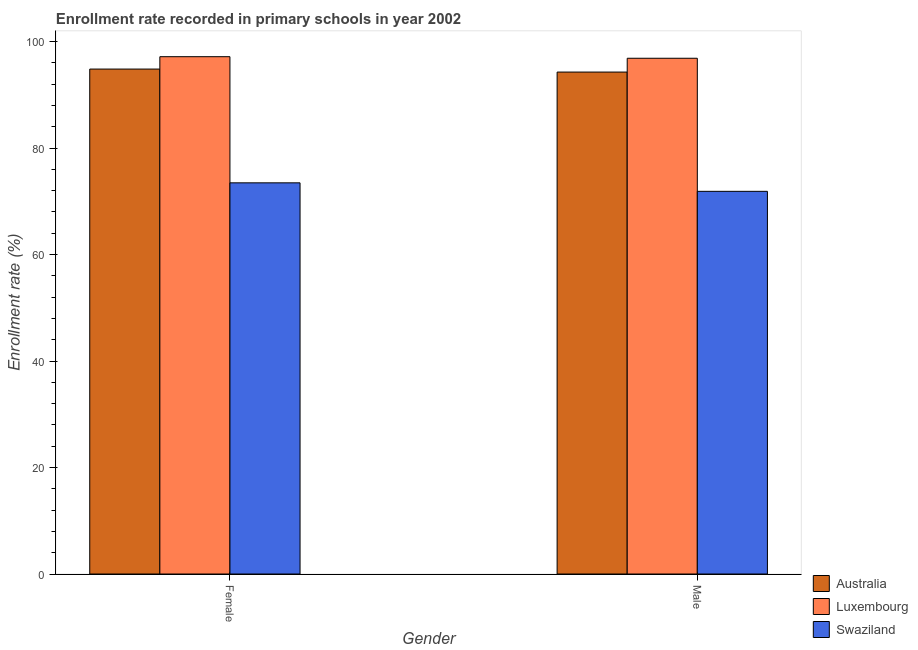Are the number of bars per tick equal to the number of legend labels?
Your answer should be compact. Yes. How many bars are there on the 2nd tick from the right?
Ensure brevity in your answer.  3. What is the label of the 2nd group of bars from the left?
Give a very brief answer. Male. What is the enrollment rate of female students in Australia?
Offer a terse response. 94.83. Across all countries, what is the maximum enrollment rate of female students?
Provide a short and direct response. 97.16. Across all countries, what is the minimum enrollment rate of male students?
Your response must be concise. 71.87. In which country was the enrollment rate of male students maximum?
Your response must be concise. Luxembourg. In which country was the enrollment rate of male students minimum?
Make the answer very short. Swaziland. What is the total enrollment rate of male students in the graph?
Make the answer very short. 263.01. What is the difference between the enrollment rate of male students in Luxembourg and that in Australia?
Make the answer very short. 2.59. What is the difference between the enrollment rate of female students in Luxembourg and the enrollment rate of male students in Swaziland?
Your response must be concise. 25.29. What is the average enrollment rate of male students per country?
Provide a short and direct response. 87.67. What is the difference between the enrollment rate of female students and enrollment rate of male students in Australia?
Provide a succinct answer. 0.56. In how many countries, is the enrollment rate of female students greater than 32 %?
Ensure brevity in your answer.  3. What is the ratio of the enrollment rate of male students in Australia to that in Swaziland?
Provide a succinct answer. 1.31. In how many countries, is the enrollment rate of female students greater than the average enrollment rate of female students taken over all countries?
Offer a very short reply. 2. What does the 3rd bar from the left in Female represents?
Your answer should be compact. Swaziland. What does the 3rd bar from the right in Female represents?
Offer a terse response. Australia. How many bars are there?
Offer a terse response. 6. How many countries are there in the graph?
Make the answer very short. 3. What is the difference between two consecutive major ticks on the Y-axis?
Ensure brevity in your answer.  20. Does the graph contain any zero values?
Your answer should be very brief. No. How many legend labels are there?
Make the answer very short. 3. What is the title of the graph?
Make the answer very short. Enrollment rate recorded in primary schools in year 2002. What is the label or title of the X-axis?
Your response must be concise. Gender. What is the label or title of the Y-axis?
Offer a terse response. Enrollment rate (%). What is the Enrollment rate (%) of Australia in Female?
Your answer should be very brief. 94.83. What is the Enrollment rate (%) in Luxembourg in Female?
Your response must be concise. 97.16. What is the Enrollment rate (%) in Swaziland in Female?
Keep it short and to the point. 73.47. What is the Enrollment rate (%) in Australia in Male?
Give a very brief answer. 94.27. What is the Enrollment rate (%) in Luxembourg in Male?
Make the answer very short. 96.87. What is the Enrollment rate (%) of Swaziland in Male?
Provide a succinct answer. 71.87. Across all Gender, what is the maximum Enrollment rate (%) in Australia?
Your answer should be compact. 94.83. Across all Gender, what is the maximum Enrollment rate (%) of Luxembourg?
Offer a terse response. 97.16. Across all Gender, what is the maximum Enrollment rate (%) in Swaziland?
Make the answer very short. 73.47. Across all Gender, what is the minimum Enrollment rate (%) in Australia?
Make the answer very short. 94.27. Across all Gender, what is the minimum Enrollment rate (%) of Luxembourg?
Ensure brevity in your answer.  96.87. Across all Gender, what is the minimum Enrollment rate (%) of Swaziland?
Give a very brief answer. 71.87. What is the total Enrollment rate (%) of Australia in the graph?
Your response must be concise. 189.11. What is the total Enrollment rate (%) in Luxembourg in the graph?
Your response must be concise. 194.03. What is the total Enrollment rate (%) of Swaziland in the graph?
Keep it short and to the point. 145.34. What is the difference between the Enrollment rate (%) of Australia in Female and that in Male?
Provide a short and direct response. 0.56. What is the difference between the Enrollment rate (%) in Luxembourg in Female and that in Male?
Offer a terse response. 0.29. What is the difference between the Enrollment rate (%) of Swaziland in Female and that in Male?
Your answer should be compact. 1.6. What is the difference between the Enrollment rate (%) in Australia in Female and the Enrollment rate (%) in Luxembourg in Male?
Provide a short and direct response. -2.03. What is the difference between the Enrollment rate (%) of Australia in Female and the Enrollment rate (%) of Swaziland in Male?
Provide a short and direct response. 22.96. What is the difference between the Enrollment rate (%) in Luxembourg in Female and the Enrollment rate (%) in Swaziland in Male?
Provide a short and direct response. 25.29. What is the average Enrollment rate (%) in Australia per Gender?
Your response must be concise. 94.55. What is the average Enrollment rate (%) of Luxembourg per Gender?
Your answer should be very brief. 97.01. What is the average Enrollment rate (%) of Swaziland per Gender?
Your answer should be very brief. 72.67. What is the difference between the Enrollment rate (%) in Australia and Enrollment rate (%) in Luxembourg in Female?
Provide a short and direct response. -2.33. What is the difference between the Enrollment rate (%) in Australia and Enrollment rate (%) in Swaziland in Female?
Your answer should be very brief. 21.37. What is the difference between the Enrollment rate (%) in Luxembourg and Enrollment rate (%) in Swaziland in Female?
Provide a succinct answer. 23.69. What is the difference between the Enrollment rate (%) of Australia and Enrollment rate (%) of Luxembourg in Male?
Your answer should be very brief. -2.59. What is the difference between the Enrollment rate (%) of Australia and Enrollment rate (%) of Swaziland in Male?
Provide a short and direct response. 22.4. What is the difference between the Enrollment rate (%) in Luxembourg and Enrollment rate (%) in Swaziland in Male?
Your response must be concise. 25. What is the ratio of the Enrollment rate (%) of Luxembourg in Female to that in Male?
Your answer should be compact. 1. What is the ratio of the Enrollment rate (%) in Swaziland in Female to that in Male?
Give a very brief answer. 1.02. What is the difference between the highest and the second highest Enrollment rate (%) of Australia?
Offer a very short reply. 0.56. What is the difference between the highest and the second highest Enrollment rate (%) in Luxembourg?
Provide a short and direct response. 0.29. What is the difference between the highest and the second highest Enrollment rate (%) in Swaziland?
Ensure brevity in your answer.  1.6. What is the difference between the highest and the lowest Enrollment rate (%) of Australia?
Offer a very short reply. 0.56. What is the difference between the highest and the lowest Enrollment rate (%) of Luxembourg?
Make the answer very short. 0.29. What is the difference between the highest and the lowest Enrollment rate (%) of Swaziland?
Your response must be concise. 1.6. 